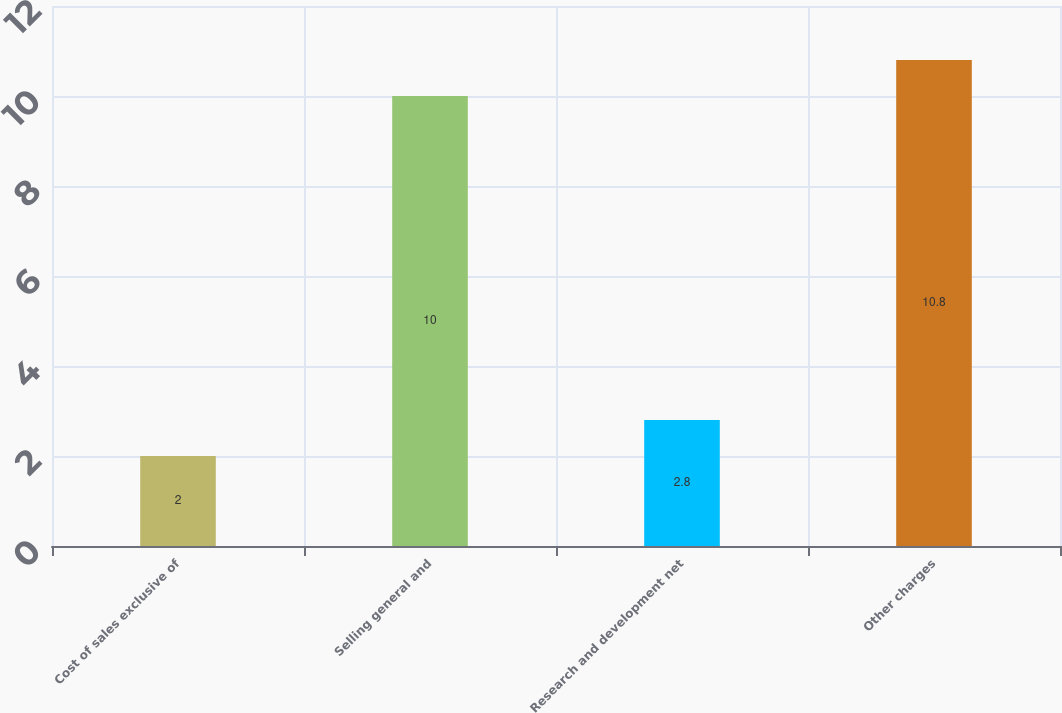Convert chart to OTSL. <chart><loc_0><loc_0><loc_500><loc_500><bar_chart><fcel>Cost of sales exclusive of<fcel>Selling general and<fcel>Research and development net<fcel>Other charges<nl><fcel>2<fcel>10<fcel>2.8<fcel>10.8<nl></chart> 